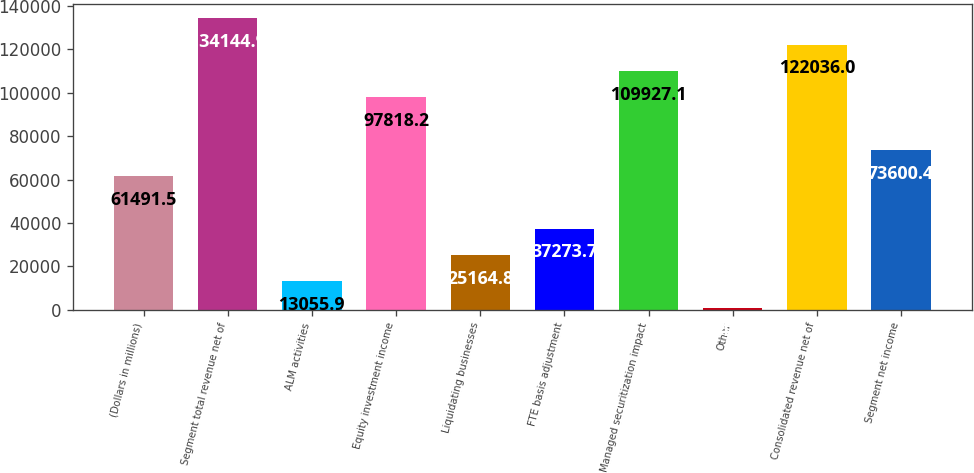<chart> <loc_0><loc_0><loc_500><loc_500><bar_chart><fcel>(Dollars in millions)<fcel>Segment total revenue net of<fcel>ALM activities<fcel>Equity investment income<fcel>Liquidating businesses<fcel>FTE basis adjustment<fcel>Managed securitization impact<fcel>Other<fcel>Consolidated revenue net of<fcel>Segment net income<nl><fcel>61491.5<fcel>134145<fcel>13055.9<fcel>97818.2<fcel>25164.8<fcel>37273.7<fcel>109927<fcel>947<fcel>122036<fcel>73600.4<nl></chart> 